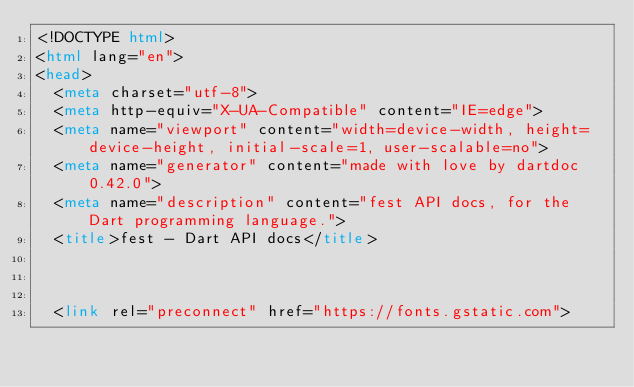<code> <loc_0><loc_0><loc_500><loc_500><_HTML_><!DOCTYPE html>
<html lang="en">
<head>
  <meta charset="utf-8">
  <meta http-equiv="X-UA-Compatible" content="IE=edge">
  <meta name="viewport" content="width=device-width, height=device-height, initial-scale=1, user-scalable=no">
  <meta name="generator" content="made with love by dartdoc 0.42.0">
  <meta name="description" content="fest API docs, for the Dart programming language.">
  <title>fest - Dart API docs</title>


  
  <link rel="preconnect" href="https://fonts.gstatic.com"></code> 